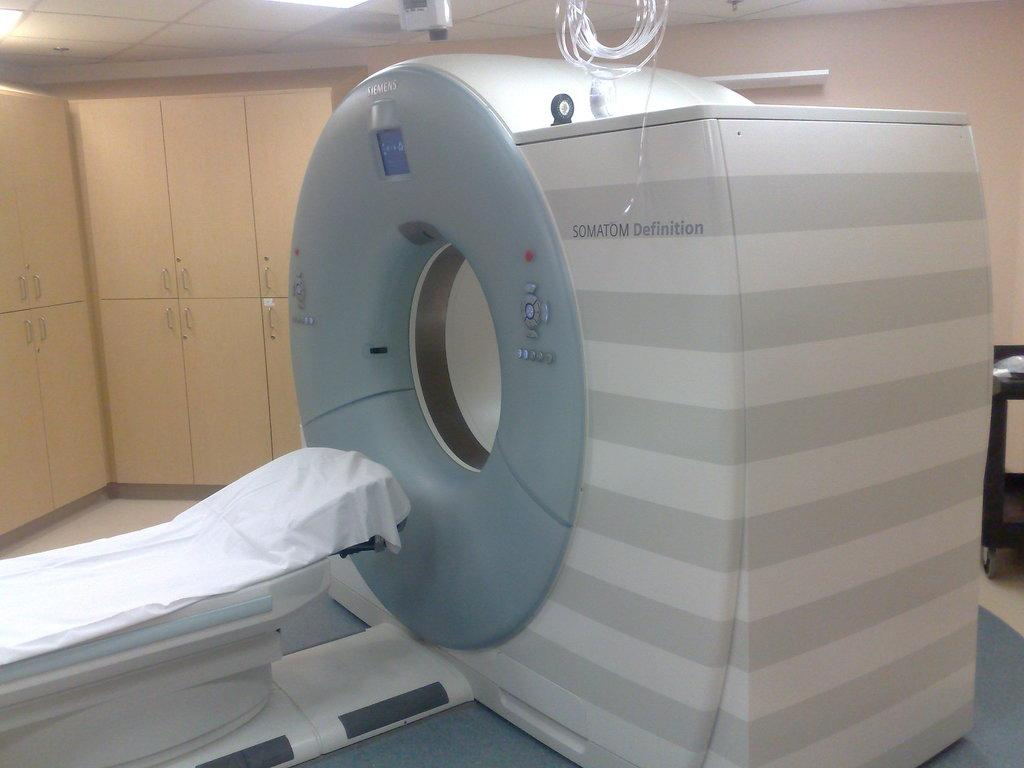What medical imaging device is present in the image? There is a computer computed tomography (CT) in the image. What is the patient likely to use during the procedure? The patient is likely to use the bed in the image during the procedure. What is covering the patient or equipment in the image? There is a white cloth in the image. What is used to connect the CT machine to the power source or other devices? There are wires in the image. What is the surface on which the bed and other equipment are placed? There is a floor in the image. Where are additional supplies or equipment stored in the room? There are cupboards in the image. What provides illumination in the room during the procedure? There is a light in the image. Can you see an umbrella being used to protect the CT machine from the rain in the image? No, there is no umbrella present in the image, and the CT machine is not exposed to rain. 